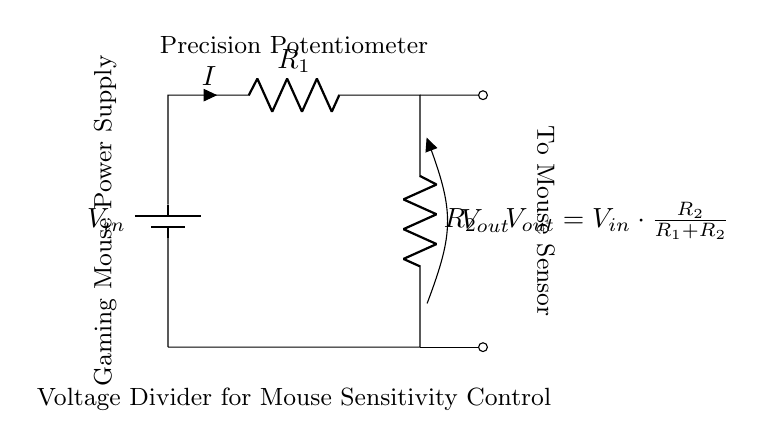What is the input voltage in this circuit? The input voltage is represented as Vin in the circuit, but the specific numerical value isn't labeled in the diagram. It typically would be determined based on external power supply specifications.
Answer: Vin What does the output voltage depend on? The output voltage, Vout, depends on the resistor values, specifically R1 and R2, as well as the input voltage. The formula provided indicates that Vout is a fraction of Vin altered by the resistor ratio.
Answer: R1 and R2 How many resistors are present in this circuit? There are two resistors labeled R1 and R2. Each has a distinct value that affects the voltage division.
Answer: Two What type of circuit is this? This is a voltage divider circuit, which is designed to create a specific voltage output based on input voltage and the values of the resistors in series.
Answer: Voltage divider What is the purpose of this circuit in relation to gaming mice? The purpose is to provide precise mouse sensitivity control by adjusting the output voltage that further influences the mouse sensor's performance.
Answer: Sensitivity control What is the relationship between Vout and Vin expressed in the circuit? The relationship is given by the formula Vout = Vin times the ratio of R2 to the sum of R1 and R2, indicating how the output voltage will be a portion of the input voltage depending on the resistor values.
Answer: Vout = Vin * (R2 / (R1 + R2)) 